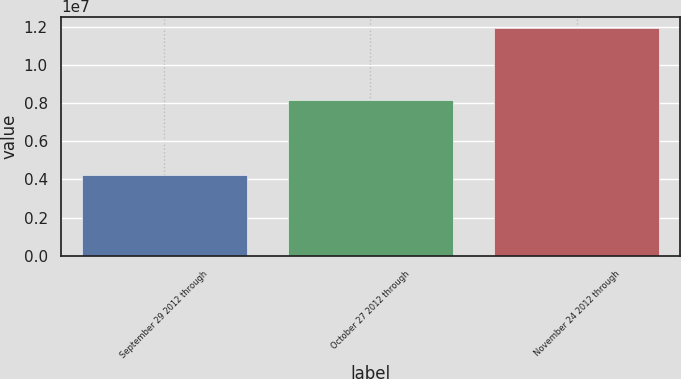Convert chart to OTSL. <chart><loc_0><loc_0><loc_500><loc_500><bar_chart><fcel>September 29 2012 through<fcel>October 27 2012 through<fcel>November 24 2012 through<nl><fcel>4.24e+06<fcel>8.1341e+06<fcel>1.19309e+07<nl></chart> 